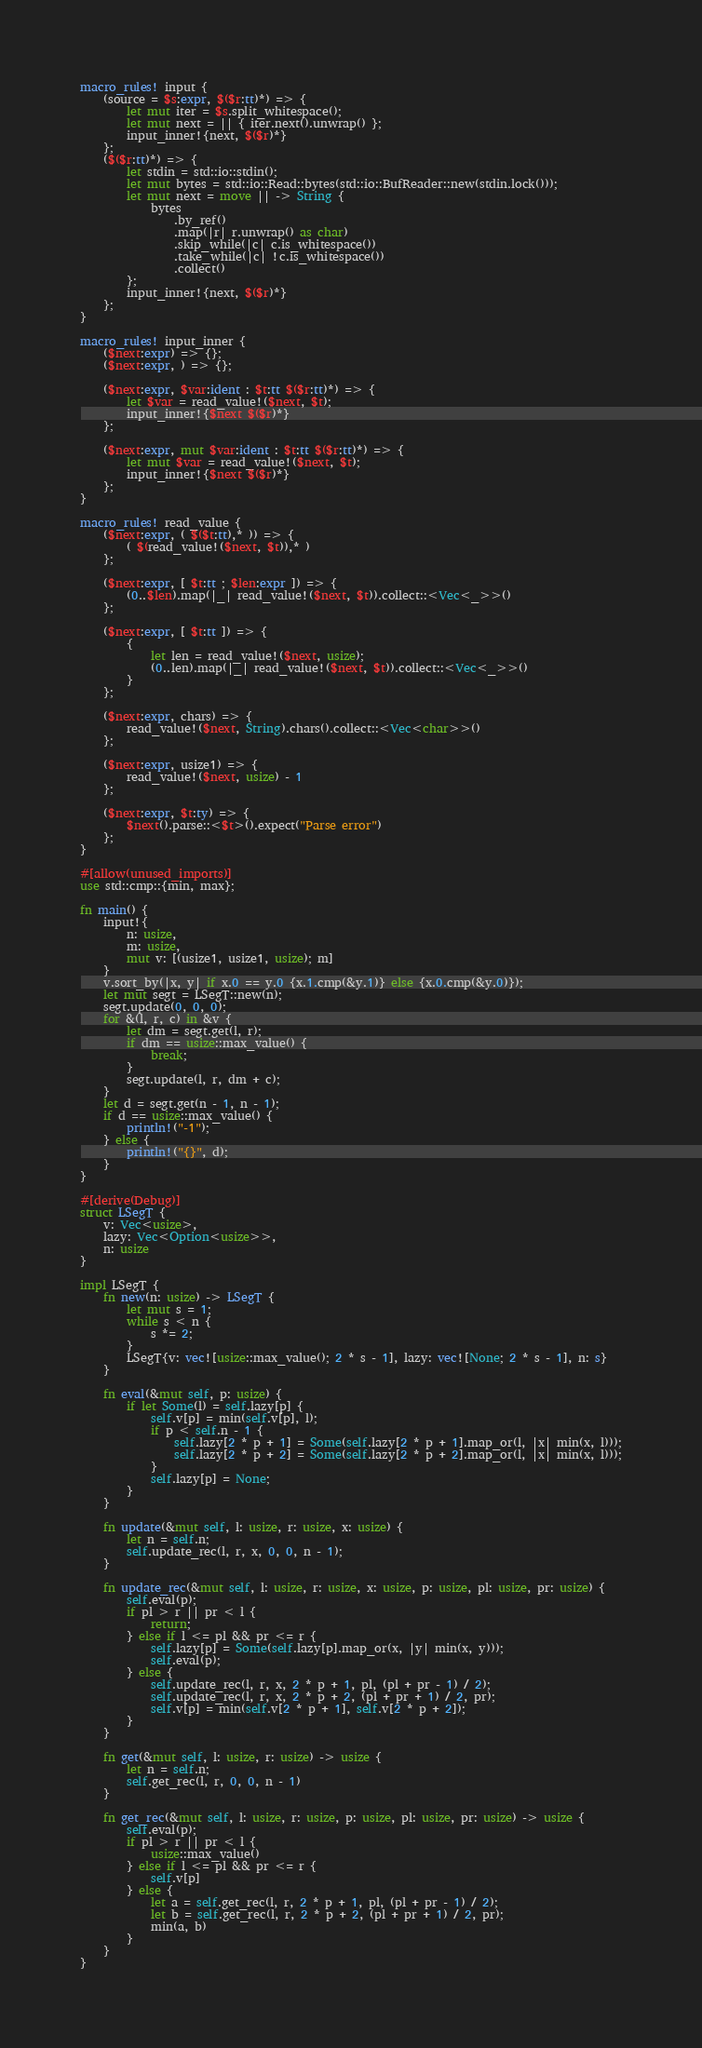<code> <loc_0><loc_0><loc_500><loc_500><_Rust_>macro_rules! input {
    (source = $s:expr, $($r:tt)*) => {
        let mut iter = $s.split_whitespace();
        let mut next = || { iter.next().unwrap() };
        input_inner!{next, $($r)*}
    };
    ($($r:tt)*) => {
        let stdin = std::io::stdin();
        let mut bytes = std::io::Read::bytes(std::io::BufReader::new(stdin.lock()));
        let mut next = move || -> String {
            bytes
                .by_ref()
                .map(|r| r.unwrap() as char)
                .skip_while(|c| c.is_whitespace())
                .take_while(|c| !c.is_whitespace())
                .collect()
        };
        input_inner!{next, $($r)*}
    };
}

macro_rules! input_inner {
    ($next:expr) => {};
    ($next:expr, ) => {};

    ($next:expr, $var:ident : $t:tt $($r:tt)*) => {
        let $var = read_value!($next, $t);
        input_inner!{$next $($r)*}
    };

    ($next:expr, mut $var:ident : $t:tt $($r:tt)*) => {
        let mut $var = read_value!($next, $t);
        input_inner!{$next $($r)*}
    };
}

macro_rules! read_value {
    ($next:expr, ( $($t:tt),* )) => {
        ( $(read_value!($next, $t)),* )
    };

    ($next:expr, [ $t:tt ; $len:expr ]) => {
        (0..$len).map(|_| read_value!($next, $t)).collect::<Vec<_>>()
    };

    ($next:expr, [ $t:tt ]) => {
        {
            let len = read_value!($next, usize);
            (0..len).map(|_| read_value!($next, $t)).collect::<Vec<_>>()
        }
    };

    ($next:expr, chars) => {
        read_value!($next, String).chars().collect::<Vec<char>>()
    };

    ($next:expr, usize1) => {
        read_value!($next, usize) - 1
    };

    ($next:expr, $t:ty) => {
        $next().parse::<$t>().expect("Parse error")
    };
}

#[allow(unused_imports)]
use std::cmp::{min, max};

fn main() {
    input!{
        n: usize,
        m: usize,
        mut v: [(usize1, usize1, usize); m]
    }
    v.sort_by(|x, y| if x.0 == y.0 {x.1.cmp(&y.1)} else {x.0.cmp(&y.0)});
    let mut segt = LSegT::new(n);
    segt.update(0, 0, 0);
    for &(l, r, c) in &v {
        let dm = segt.get(l, r);
        if dm == usize::max_value() {
            break;
        }
        segt.update(l, r, dm + c);
    }
    let d = segt.get(n - 1, n - 1);
    if d == usize::max_value() {
        println!("-1");
    } else {
        println!("{}", d);
    }
}

#[derive(Debug)]
struct LSegT {
    v: Vec<usize>,
    lazy: Vec<Option<usize>>,
    n: usize
}

impl LSegT {
    fn new(n: usize) -> LSegT {
        let mut s = 1;
        while s < n {
            s *= 2;
        }
        LSegT{v: vec![usize::max_value(); 2 * s - 1], lazy: vec![None; 2 * s - 1], n: s}
    }

    fn eval(&mut self, p: usize) {
        if let Some(l) = self.lazy[p] {
            self.v[p] = min(self.v[p], l);
            if p < self.n - 1 {
                self.lazy[2 * p + 1] = Some(self.lazy[2 * p + 1].map_or(l, |x| min(x, l)));
                self.lazy[2 * p + 2] = Some(self.lazy[2 * p + 2].map_or(l, |x| min(x, l)));
            }
            self.lazy[p] = None;
        }
    }

    fn update(&mut self, l: usize, r: usize, x: usize) {
        let n = self.n;
        self.update_rec(l, r, x, 0, 0, n - 1);
    }

    fn update_rec(&mut self, l: usize, r: usize, x: usize, p: usize, pl: usize, pr: usize) {
        self.eval(p);
        if pl > r || pr < l {
            return;
        } else if l <= pl && pr <= r {
            self.lazy[p] = Some(self.lazy[p].map_or(x, |y| min(x, y)));
            self.eval(p);
        } else {
            self.update_rec(l, r, x, 2 * p + 1, pl, (pl + pr - 1) / 2);
            self.update_rec(l, r, x, 2 * p + 2, (pl + pr + 1) / 2, pr);
            self.v[p] = min(self.v[2 * p + 1], self.v[2 * p + 2]);
        }
    }

    fn get(&mut self, l: usize, r: usize) -> usize {
        let n = self.n;
        self.get_rec(l, r, 0, 0, n - 1)
    }

    fn get_rec(&mut self, l: usize, r: usize, p: usize, pl: usize, pr: usize) -> usize {
        self.eval(p);
        if pl > r || pr < l {
            usize::max_value()
        } else if l <= pl && pr <= r {
            self.v[p]
        } else {
            let a = self.get_rec(l, r, 2 * p + 1, pl, (pl + pr - 1) / 2);
            let b = self.get_rec(l, r, 2 * p + 2, (pl + pr + 1) / 2, pr);
            min(a, b)
        }
    }
}
</code> 